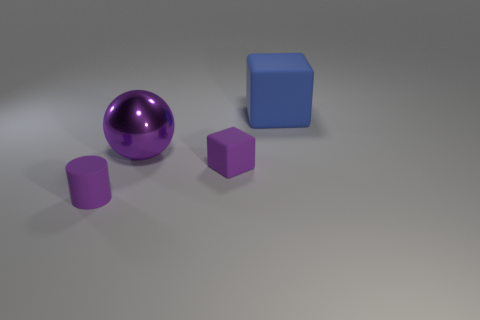Add 2 cylinders. How many objects exist? 6 Subtract 0 red cylinders. How many objects are left? 4 Subtract all small blocks. Subtract all tiny purple matte things. How many objects are left? 1 Add 1 purple metal objects. How many purple metal objects are left? 2 Add 2 big gray rubber blocks. How many big gray rubber blocks exist? 2 